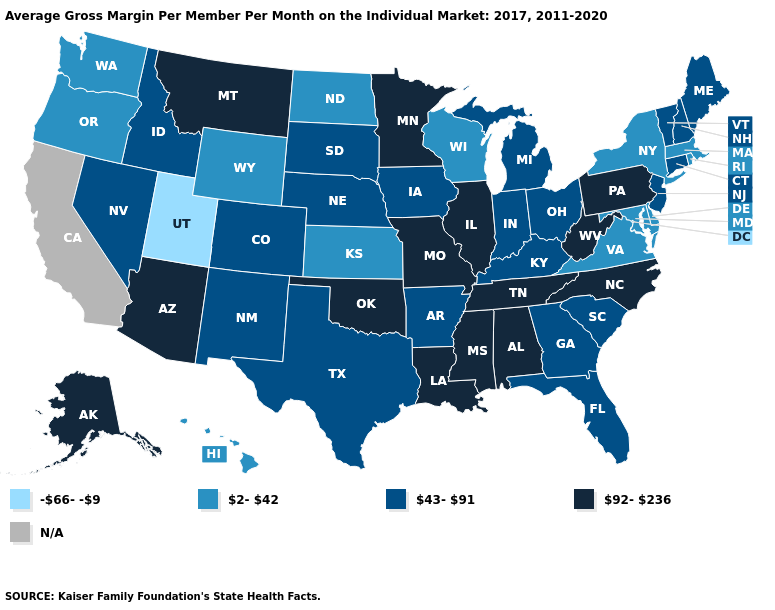What is the value of New York?
Short answer required. 2-42. Does Utah have the lowest value in the West?
Short answer required. Yes. What is the value of North Dakota?
Be succinct. 2-42. Which states have the lowest value in the USA?
Write a very short answer. Utah. Name the states that have a value in the range 43-91?
Be succinct. Arkansas, Colorado, Connecticut, Florida, Georgia, Idaho, Indiana, Iowa, Kentucky, Maine, Michigan, Nebraska, Nevada, New Hampshire, New Jersey, New Mexico, Ohio, South Carolina, South Dakota, Texas, Vermont. What is the highest value in states that border Pennsylvania?
Keep it brief. 92-236. What is the lowest value in states that border South Dakota?
Quick response, please. 2-42. What is the lowest value in the USA?
Quick response, please. -66--9. Name the states that have a value in the range 92-236?
Concise answer only. Alabama, Alaska, Arizona, Illinois, Louisiana, Minnesota, Mississippi, Missouri, Montana, North Carolina, Oklahoma, Pennsylvania, Tennessee, West Virginia. Name the states that have a value in the range 92-236?
Keep it brief. Alabama, Alaska, Arizona, Illinois, Louisiana, Minnesota, Mississippi, Missouri, Montana, North Carolina, Oklahoma, Pennsylvania, Tennessee, West Virginia. Does the map have missing data?
Short answer required. Yes. Name the states that have a value in the range 43-91?
Be succinct. Arkansas, Colorado, Connecticut, Florida, Georgia, Idaho, Indiana, Iowa, Kentucky, Maine, Michigan, Nebraska, Nevada, New Hampshire, New Jersey, New Mexico, Ohio, South Carolina, South Dakota, Texas, Vermont. Does the map have missing data?
Be succinct. Yes. 